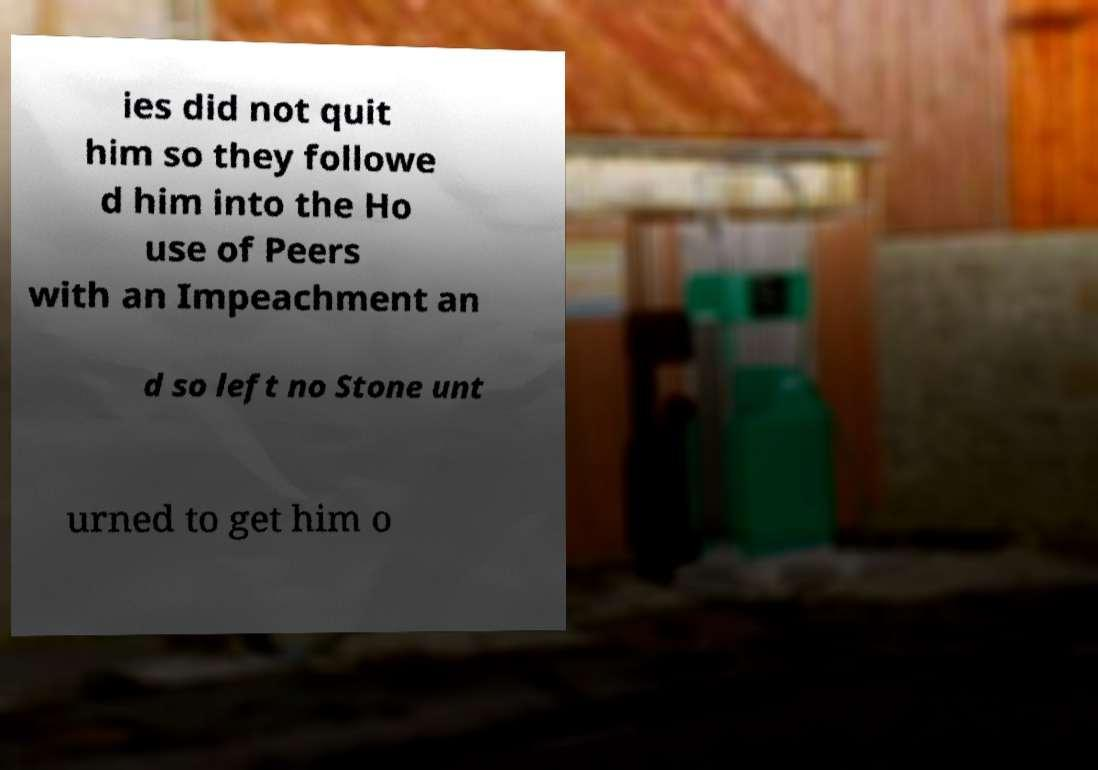Could you assist in decoding the text presented in this image and type it out clearly? ies did not quit him so they followe d him into the Ho use of Peers with an Impeachment an d so left no Stone unt urned to get him o 